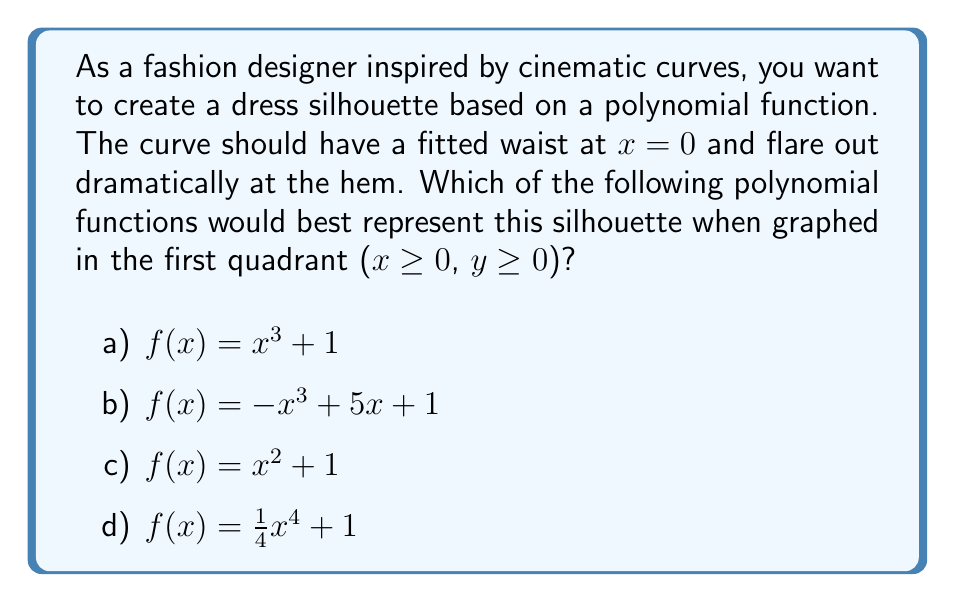Give your solution to this math problem. To determine the best polynomial function for the desired dress silhouette, let's analyze each option:

1. $f(x) = x^3 + 1$
   This cubic function starts at (0, 1) and increases rapidly as x increases. However, it doesn't have a flattened section near x = 0 for the fitted waist.

2. $f(x) = -x^3 + 5x + 1$
   This cubic function has a negative leading coefficient, causing it to curve downward as x increases, which doesn't match our desired silhouette.

3. $f(x) = x^2 + 1$
   This quadratic function provides a gentle curve, but it may not flare out dramatically enough at the hem for the desired effect.

4. $f(x) = \frac{1}{4}x^4 + 1$
   This quartic function is the best option because:
   - At x = 0, f(0) = 1, representing the fitted waist.
   - Near x = 0, the curve remains relatively flat due to the small coefficient and high power of x.
   - As x increases, the function grows rapidly, creating a dramatic flare at the hem.

To visualize this, we can sketch the graph:

[asy]
import graph;
size(200,200);
real f(real x) {return 0.25*x^4 + 1;}
draw(graph(f,0,1.5),blue);
draw((0,0)--(1.5,0),black);
draw((0,0)--(0,6),black);
label("x",point(1.5,0),SE);
label("y",point(0,6),NW);
label("f(x)",point(1.5,f(1.5)),SE);
[/asy]

This graph shows how the function creates a fitted waist near x = 0 and flares out dramatically as x increases, perfectly matching the desired dress silhouette.
Answer: d) $f(x) = \frac{1}{4}x^4 + 1$ 